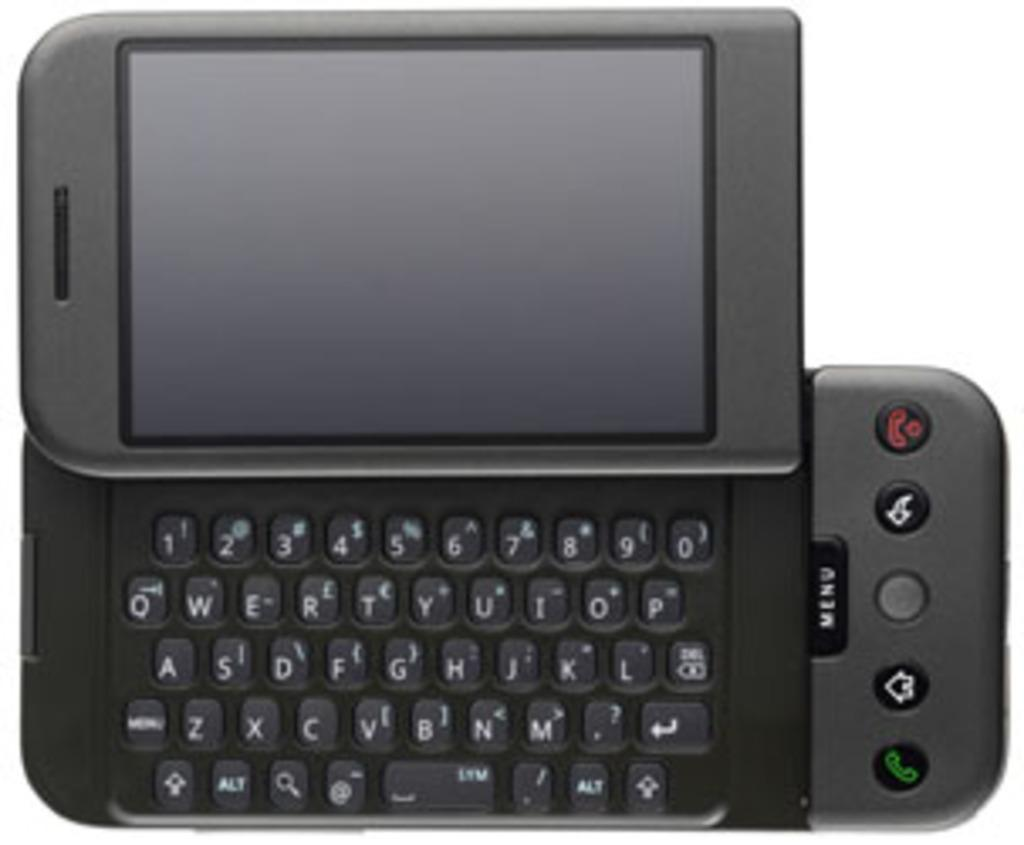<image>
Write a terse but informative summary of the picture. A sliding phone that has a button in the middle that says menu. 